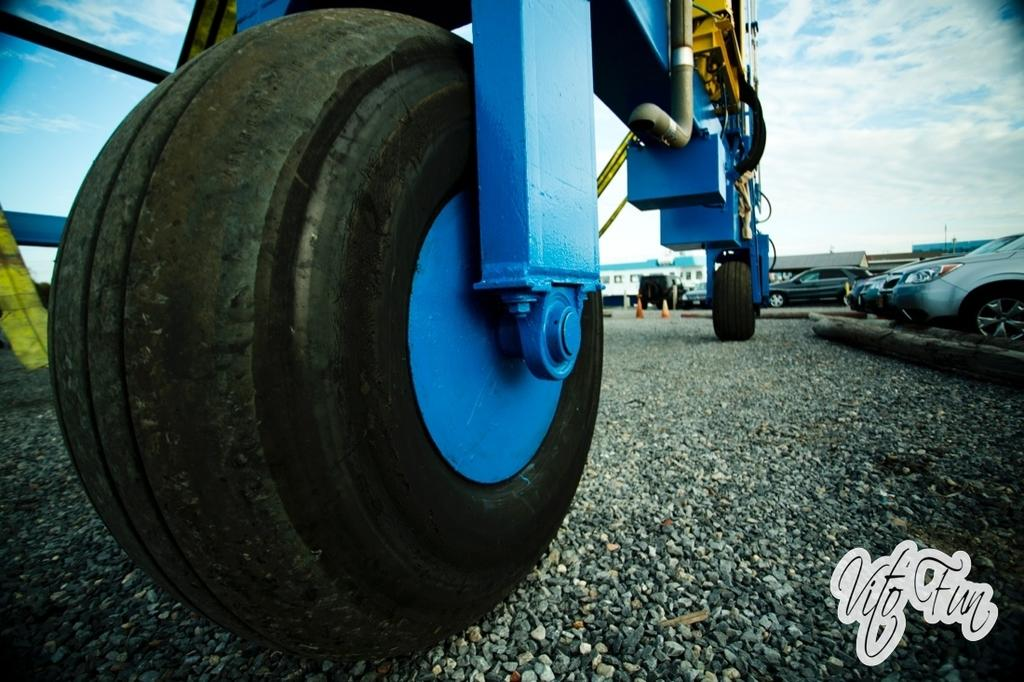What type of machine is visible in the image? There are wheels of a hydraulic machine in the image. Where is the hydraulic machine located in relation to other objects? The hydraulic machine is located beside parked cars. What type of area is depicted in the image? There is a parking lot in the image. What type of line is visible in the image? There is no line visible in the image. Is there any underwear present in the image? There is no underwear present in the image. 